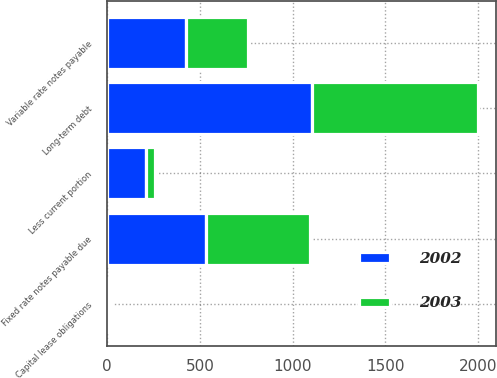Convert chart. <chart><loc_0><loc_0><loc_500><loc_500><stacked_bar_chart><ecel><fcel>Fixed rate notes payable due<fcel>Variable rate notes payable<fcel>Long-term debt<fcel>Capital lease obligations<fcel>Less current portion<nl><fcel>2003<fcel>559.3<fcel>334.2<fcel>893.5<fcel>11.8<fcel>48.6<nl><fcel>2002<fcel>532.6<fcel>422.5<fcel>1105.1<fcel>8.5<fcel>206.7<nl></chart> 